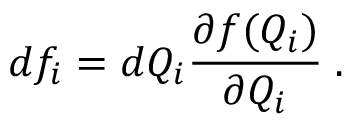<formula> <loc_0><loc_0><loc_500><loc_500>d f _ { i } = d Q _ { i } \frac { \partial f ( Q _ { i } ) } { \partial Q _ { i } } \, .</formula> 